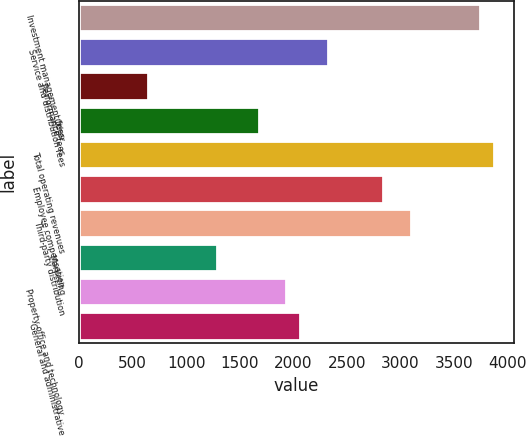Convert chart to OTSL. <chart><loc_0><loc_0><loc_500><loc_500><bar_chart><fcel>Investment management fees<fcel>Service and distribution fees<fcel>Performance fees<fcel>Other<fcel>Total operating revenues<fcel>Employee compensation<fcel>Third-party distribution<fcel>Marketing<fcel>Property office and technology<fcel>General and administrative<nl><fcel>3740.26<fcel>2321.61<fcel>645.09<fcel>1676.79<fcel>3869.23<fcel>2837.49<fcel>3095.41<fcel>1289.9<fcel>1934.71<fcel>2063.68<nl></chart> 